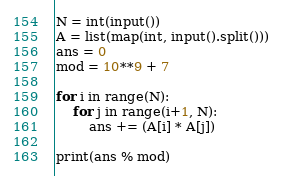<code> <loc_0><loc_0><loc_500><loc_500><_Python_>N = int(input())
A = list(map(int, input().split()))
ans = 0
mod = 10**9 + 7

for i in range(N):
    for j in range(i+1, N):
        ans += (A[i] * A[j])

print(ans % mod)</code> 